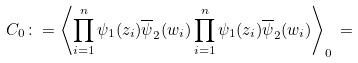Convert formula to latex. <formula><loc_0><loc_0><loc_500><loc_500>C _ { 0 } \colon = \left \langle \prod _ { i = 1 } ^ { n } \psi _ { 1 } ( z _ { i } ) \overline { \psi } _ { 2 } ( w _ { i } ) \prod _ { i = 1 } ^ { n } \psi _ { 1 } ( z _ { i } ) \overline { \psi } _ { 2 } ( w _ { i } ) \right \rangle _ { 0 } \, =</formula> 